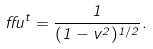Convert formula to latex. <formula><loc_0><loc_0><loc_500><loc_500>\alpha u ^ { t } = \frac { 1 } { ( 1 - v ^ { 2 } ) ^ { 1 / 2 } } .</formula> 